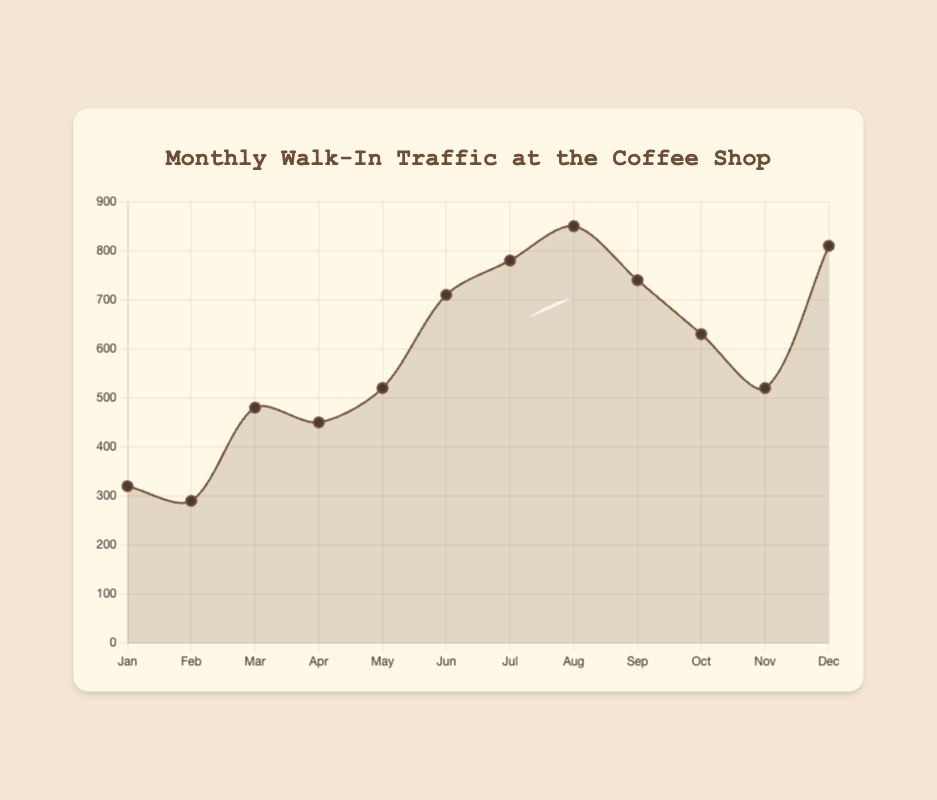What is the month with the highest walk-in traffic? The month with the highest walk-in traffic can be identified by observing the peak of the line. August is the highest point on the line plot.
Answer: August What is the total walk-in traffic for the first half of the year? Sum the traffic values from January to June: 320 (Jan) + 290 (Feb) + 480 (Mar) + 450 (Apr) + 520 (May) + 710 (Jun) = 2770.
Answer: 2770 In which month is the walk-in traffic exactly equal to 520? Find the points on the line plot and data labels where the value is 520. This happens in May and November.
Answer: May, November How much did the walk-in traffic increase from February to March? Subtract the traffic in February from March: 480 (Mar) - 290 (Feb) = 190.
Answer: 190 Which quarter had the highest average walk-in traffic? Calculate the average traffic for each quarter: 
1st quarter: (320 + 290 + 480) / 3 = 363.3; 
2nd quarter: (450 + 520 + 710) / 3 = 560; 
3rd quarter: (780 + 850 + 740) / 3 = 790; 
4th quarter: (630 + 520 + 810) / 3 = 653.3. 
The 3rd quarter has the highest average.
Answer: 3rd quarter Is there a month where the walk-in traffic is less than 300? Find the points on the line plot where the traffic value is below 300. This happens in February.
Answer: February What is the difference in walk-in traffic between July and October? Subtract the traffic in October from July: 780 (Jul) - 630 (Oct) = 150.
Answer: 150 Which month had the largest decrease in walk-in traffic compared to the previous month? Calculate the month-over-month differences and identify the largest decrease: 
Feb-Jan = -30, Mar-Feb = 190, Apr-Mar = -30, May-Apr = 70, Jun-May = 190, Jul-Jun = 70, Aug-Jul = 70, Sep-Aug = -110, Oct-Sep = -110, Nov-Oct = -110, Dec-Nov = 290. 
The largest decrease happened from December to November.
Answer: November What is the average walk-in traffic for the entire year? Sum all monthly traffic values and divide by 12: (320 + 290 + 480 + 450 + 520 + 710 + 780 + 850 + 740 + 630 + 520 + 810) / 12 = 5960 / 12 = 496.7.
Answer: 496.7 